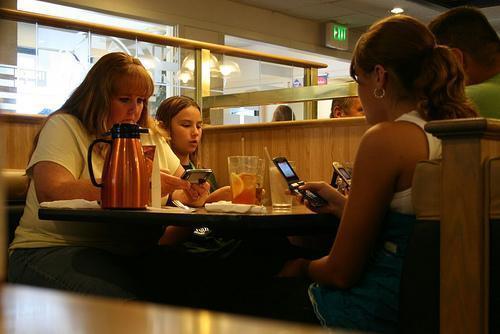How many cell phones are visible in the photo?
Give a very brief answer. 3. How many people are sitting at the table?
Give a very brief answer. 4. How many of the people have ponytails?
Give a very brief answer. 1. 